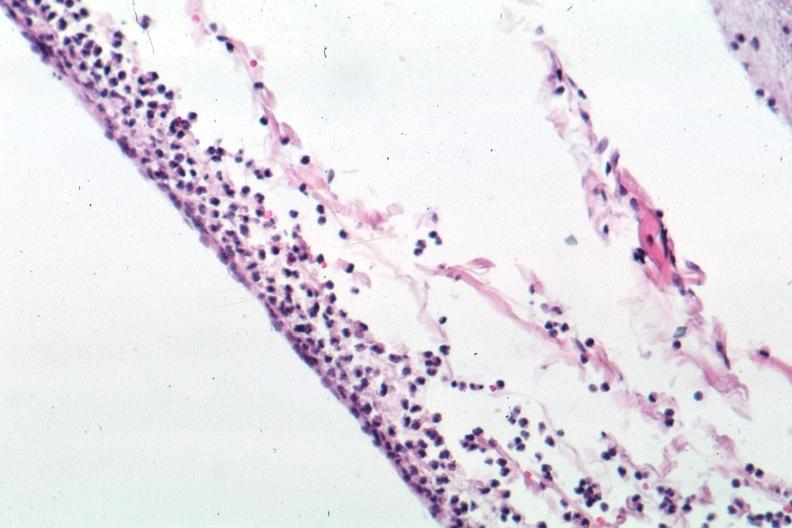s granulosa cell tumor present?
Answer the question using a single word or phrase. No 